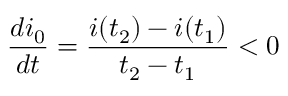<formula> <loc_0><loc_0><loc_500><loc_500>\frac { d i _ { 0 } } { d t } = \frac { i ( t _ { 2 } ) - i ( t _ { 1 } ) } { t _ { 2 } - t _ { 1 } } < 0</formula> 